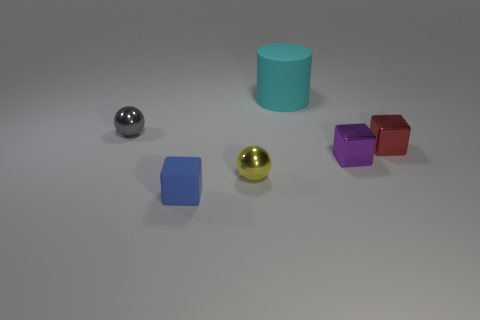Subtract all yellow spheres. How many spheres are left? 1 Subtract all tiny purple blocks. How many blocks are left? 2 Add 1 big cyan metallic cylinders. How many objects exist? 7 Subtract 1 cylinders. How many cylinders are left? 0 Subtract all gray spheres. Subtract all cyan cylinders. How many spheres are left? 1 Subtract all green spheres. How many blue blocks are left? 1 Add 6 yellow metallic spheres. How many yellow metallic spheres are left? 7 Add 1 yellow metal balls. How many yellow metal balls exist? 2 Subtract 0 green cubes. How many objects are left? 6 Subtract all spheres. How many objects are left? 4 